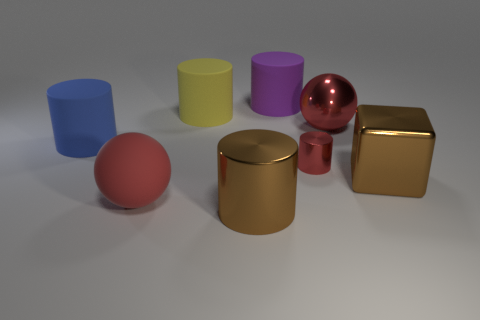Could you describe the arrangement and colors of all the objects seen in the image? Certainly! In the image, we see an array of geometric shapes. On the left, there's a translucent blue cylinder and a red sphere. Towards the center, a bright yellow cylinder pairs with a purple matte one. A reflective pink sphere sits near the middle, and on the right, a brown matte cube is adjacent to a red metallic ball. The arrangement feels almost symmetrical, and the texture variation adds depth to the scene. 